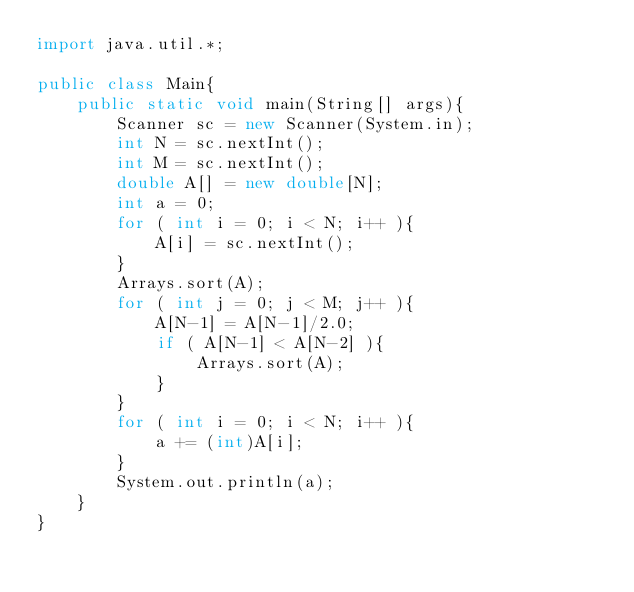<code> <loc_0><loc_0><loc_500><loc_500><_Java_>import java.util.*;

public class Main{
    public static void main(String[] args){
        Scanner sc = new Scanner(System.in);
        int N = sc.nextInt();
        int M = sc.nextInt();
        double A[] = new double[N];
        int a = 0;
        for ( int i = 0; i < N; i++ ){
            A[i] = sc.nextInt();
        }
        Arrays.sort(A);
        for ( int j = 0; j < M; j++ ){
            A[N-1] = A[N-1]/2.0;
            if ( A[N-1] < A[N-2] ){
                Arrays.sort(A);
            }
        }
        for ( int i = 0; i < N; i++ ){
            a += (int)A[i];            
        }
        System.out.println(a);
    }
}</code> 